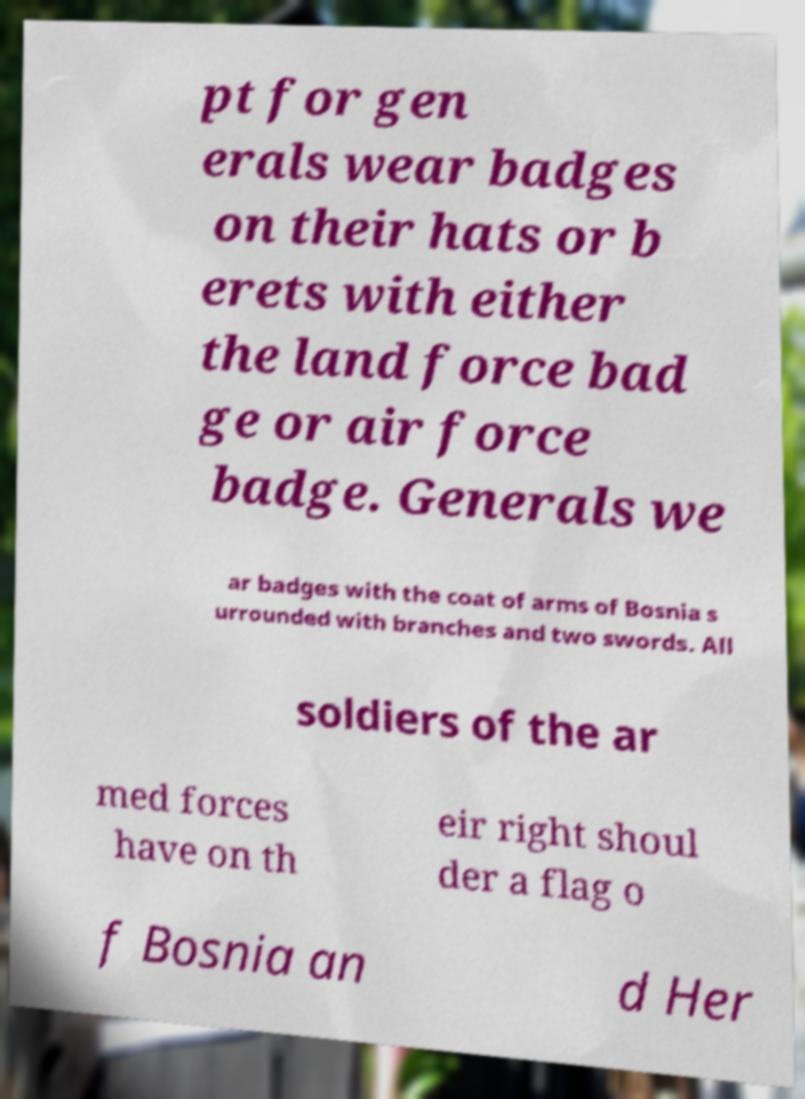There's text embedded in this image that I need extracted. Can you transcribe it verbatim? pt for gen erals wear badges on their hats or b erets with either the land force bad ge or air force badge. Generals we ar badges with the coat of arms of Bosnia s urrounded with branches and two swords. All soldiers of the ar med forces have on th eir right shoul der a flag o f Bosnia an d Her 